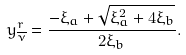<formula> <loc_0><loc_0><loc_500><loc_500>y ^ { r } _ { \overline { \nu } } = \frac { - \xi _ { a } + \sqrt { \xi _ { a } ^ { 2 } + 4 \xi _ { b } } } { 2 \xi _ { b } } .</formula> 